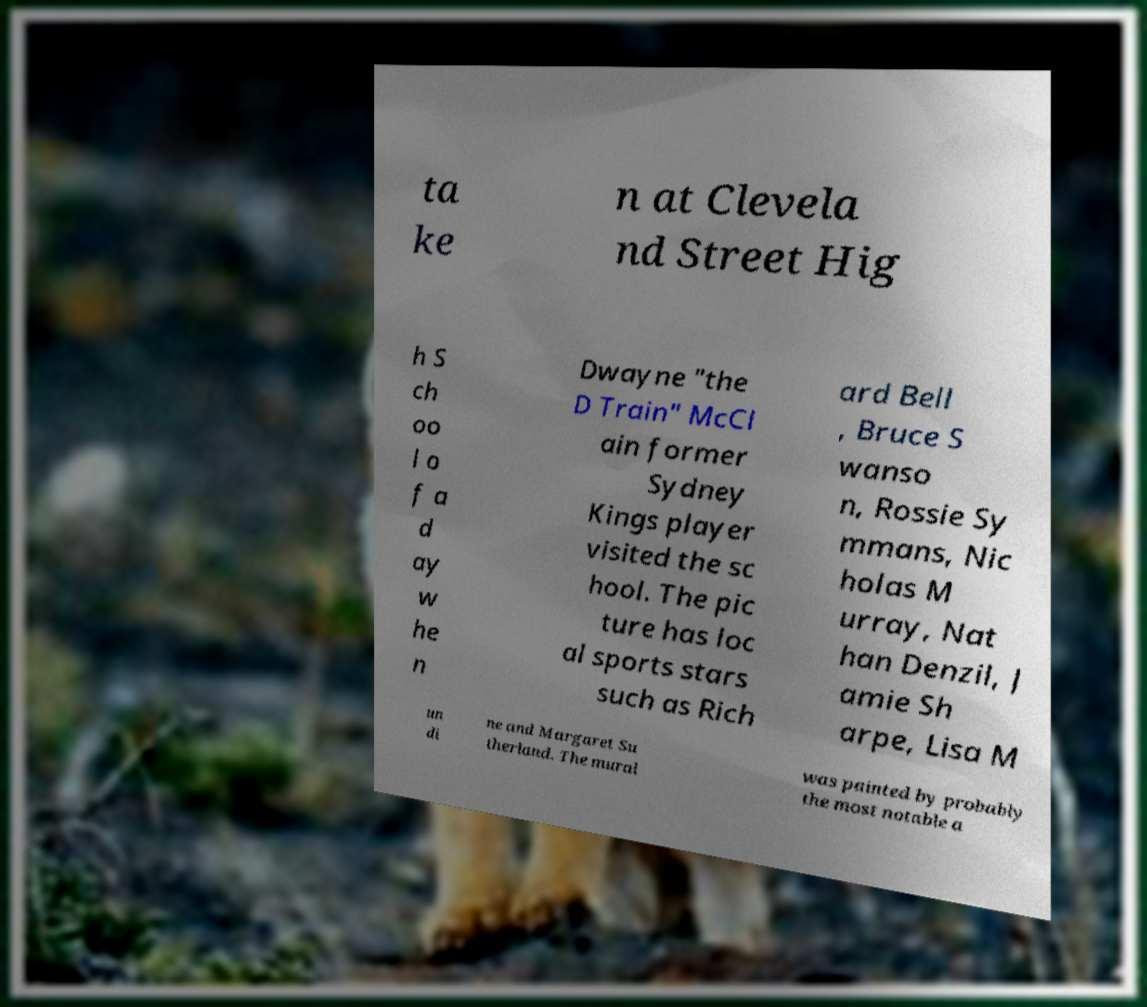Can you read and provide the text displayed in the image?This photo seems to have some interesting text. Can you extract and type it out for me? ta ke n at Clevela nd Street Hig h S ch oo l o f a d ay w he n Dwayne "the D Train" McCl ain former Sydney Kings player visited the sc hool. The pic ture has loc al sports stars such as Rich ard Bell , Bruce S wanso n, Rossie Sy mmans, Nic holas M urray, Nat han Denzil, J amie Sh arpe, Lisa M un di ne and Margaret Su therland. The mural was painted by probably the most notable a 